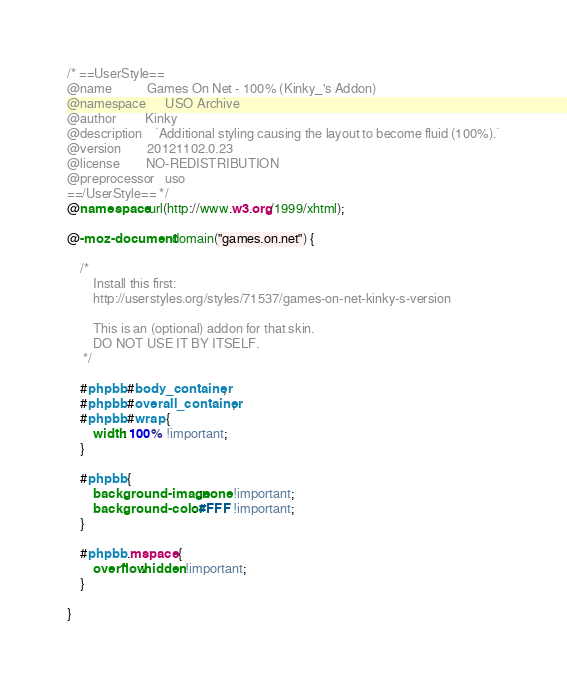Convert code to text. <code><loc_0><loc_0><loc_500><loc_500><_CSS_>/* ==UserStyle==
@name           Games On Net - 100% (Kinky_'s Addon)
@namespace      USO Archive
@author         Kinky
@description    `Additional styling causing the layout to become fluid (100%).`
@version        20121102.0.23
@license        NO-REDISTRIBUTION
@preprocessor   uso
==/UserStyle== */
@namespace url(http://www.w3.org/1999/xhtml);

@-moz-document domain("games.on.net") {

    /* 
        Install this first:
        http://userstyles.org/styles/71537/games-on-net-kinky-s-version
        
        This is an (optional) addon for that skin. 
        DO NOT USE IT BY ITSELF.        
     */
     
    #phpbb #body_container, 
    #phpbb #overall_container,
    #phpbb #wrap { 
        width: 100% !important; 
    }
    
    #phpbb {
        background-image:none !important;
        background-color: #FFF !important;
    }
    
    #phpbb .mspace {
        overflow:hidden !important;
    }   

}</code> 